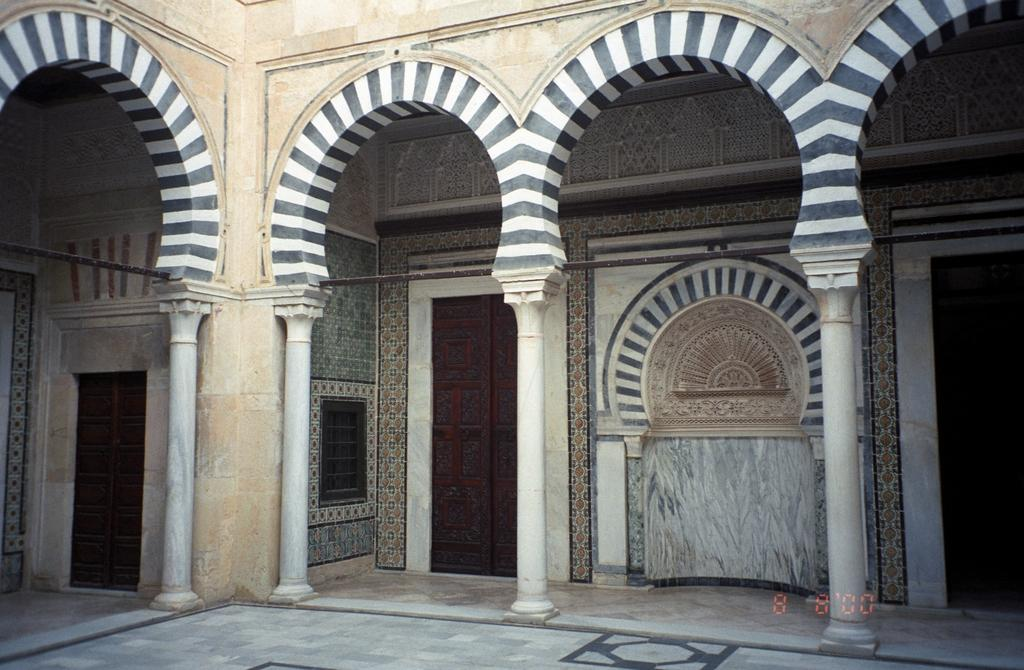What architectural features can be seen in the image? There are pillars and arch-like structures present on the building in the image. What type of entrance is available in the image? There are doors present in the image. What type of nerve can be seen in the image? There is no nerve present in the image; it features architectural elements of a building. Can you see a tiger in the image? No, there is no tiger present in the image. 